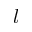<formula> <loc_0><loc_0><loc_500><loc_500>l</formula> 